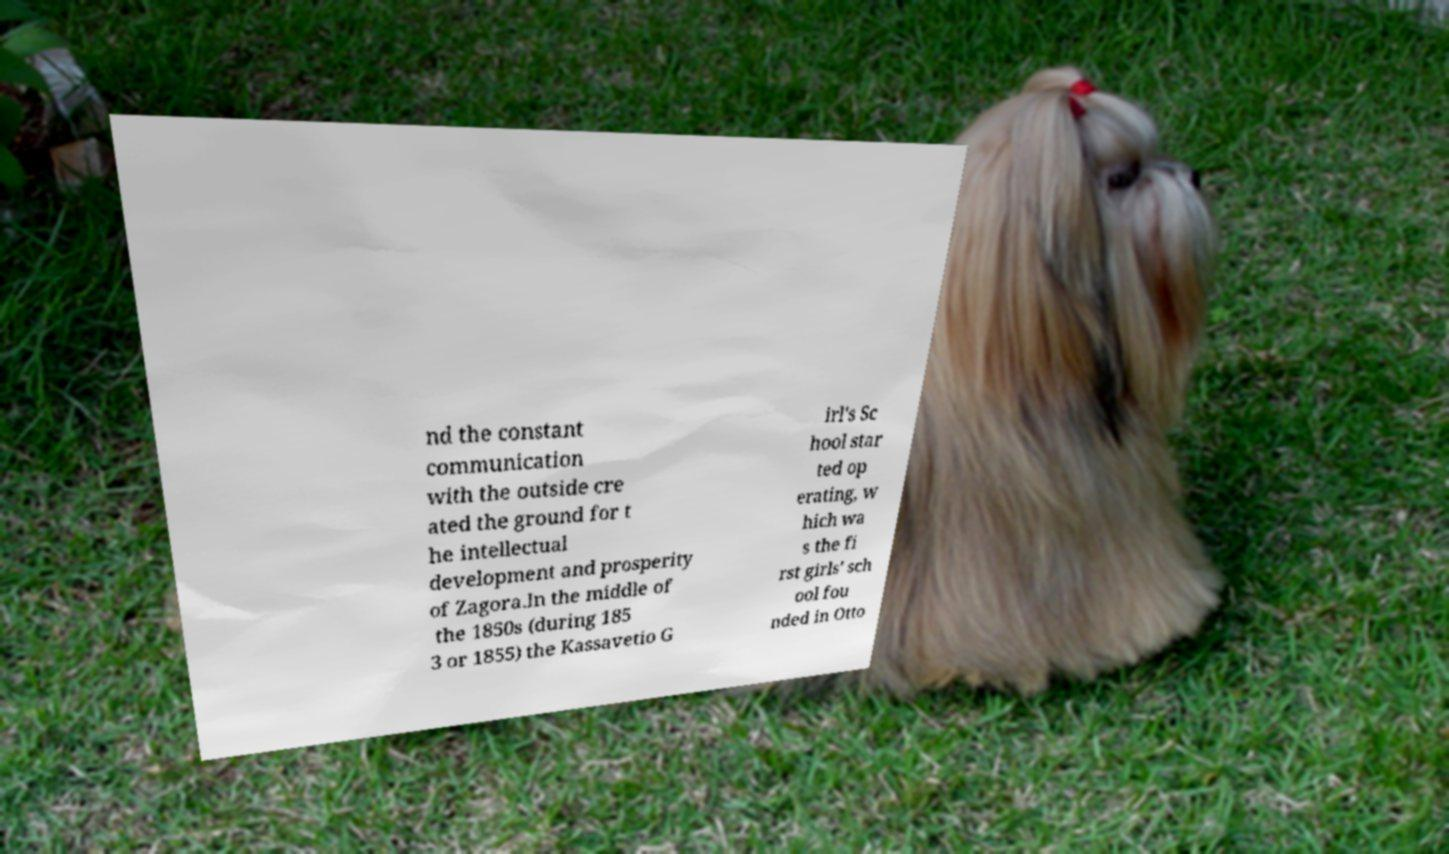For documentation purposes, I need the text within this image transcribed. Could you provide that? nd the constant communication with the outside cre ated the ground for t he intellectual development and prosperity of Zagora.In the middle of the 1850s (during 185 3 or 1855) the Kassavetio G irl's Sc hool star ted op erating, w hich wa s the fi rst girls' sch ool fou nded in Otto 